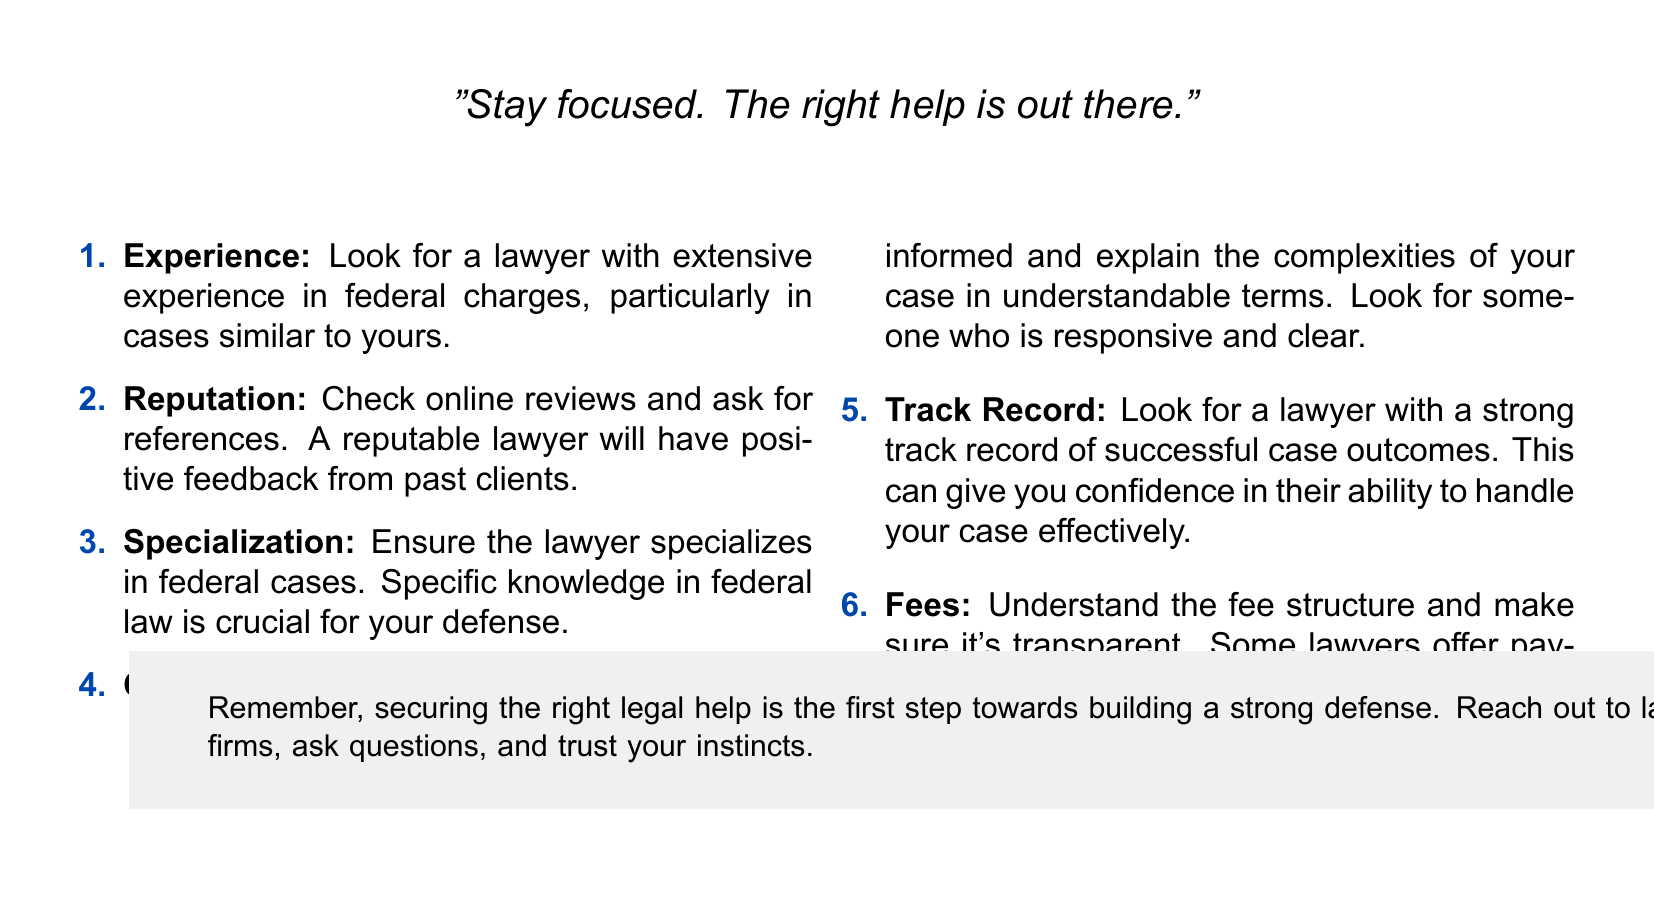what is the title of the card? The title is prominently displayed at the top of the card in a large font.
Answer: Finding the Right Legal Help how many essential qualities are listed? The document includes an enumerated list of six qualities essential for finding a lawyer.
Answer: 6 what color is used for the title text? The title text is in white color, which contrasts with the law blue background.
Answer: white what is advised regarding the lawyer’s communication? The checklist emphasizes the importance of clear and responsive communication from the lawyer.
Answer: Responsive and clear what is the recommended action regarding fees? The document recommends understanding the fee structure and ensuring transparency.
Answer: Ensure transparency what background color is used in the footer? The footer of the card has a light gray background.
Answer: light gray which phrase is mentioned to keep you motivated? A motivational phrase is included to encourage focusing on finding help.
Answer: Stay focused. The right help is out there what type of law should the lawyer specialize in? The document suggests that the lawyer should have specialization in federal cases.
Answer: Federal cases 